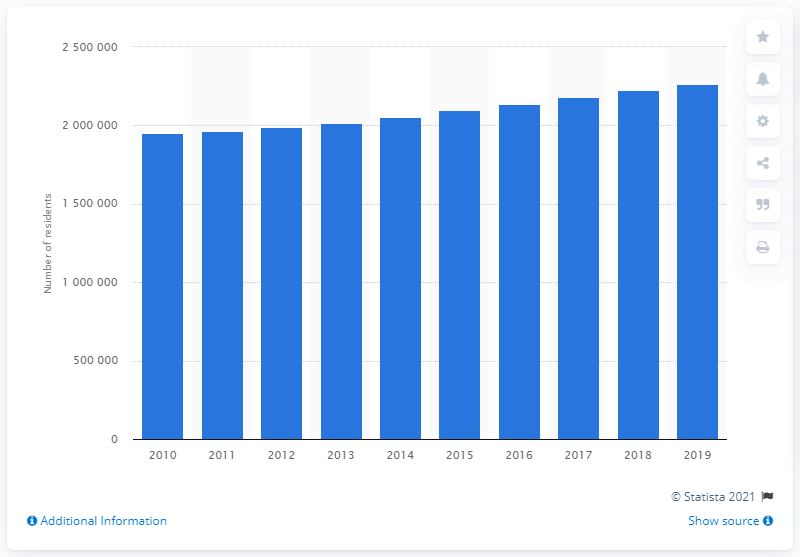What trend is shown in the population graph for the Las Vegas metropolitan area over the decade? The graph displays a steady increase in the population of the Las Vegas-Henderson-Paradise metropolitan area from 2010 to 2019, indicating a trend of consistent growth over the decade. 